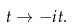<formula> <loc_0><loc_0><loc_500><loc_500>t \to - i t .</formula> 